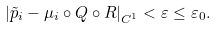<formula> <loc_0><loc_0><loc_500><loc_500>\left | \tilde { p } _ { i } - \mu _ { i } \circ Q \circ R \right | _ { C ^ { 1 } } < \varepsilon \leq \varepsilon _ { 0 } .</formula> 